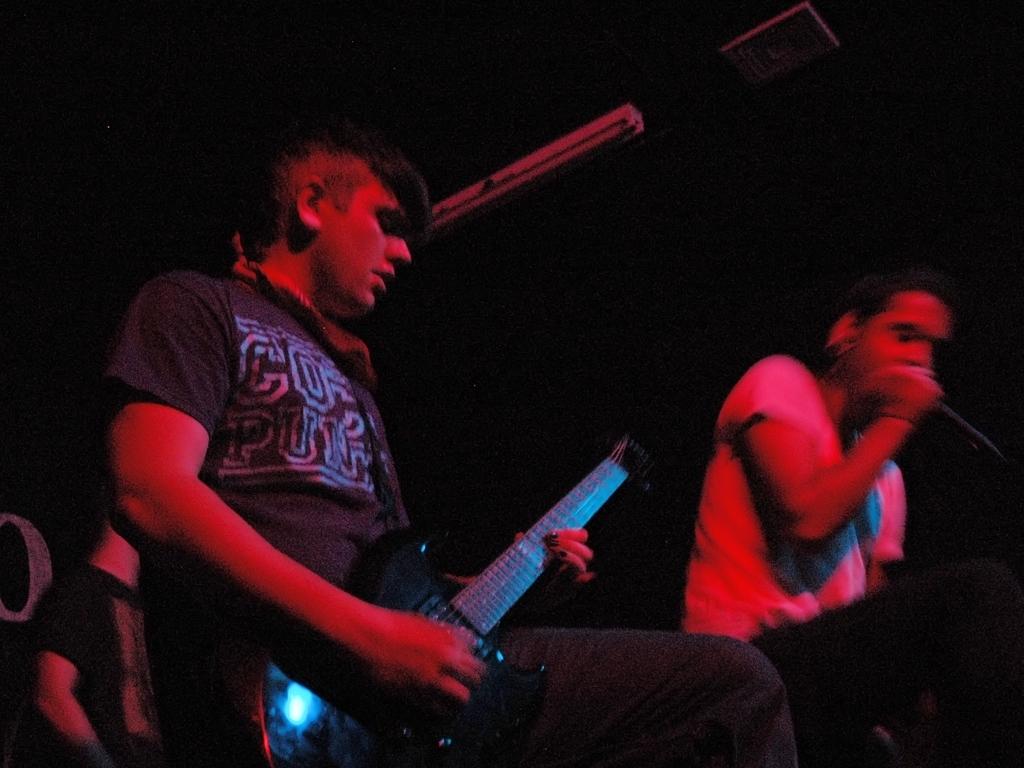What style or genre of music do the performers in the image seem to be playing? Based on their appearance and the atmosphere, it could be surmised that the performers are playing a genre of modern music, potentially rock or a sub-genre of rock. The electric guitar and the presence of a vocalist holding a microphone, along with the casual attire, suggest a music style that is energetic and expressive. 